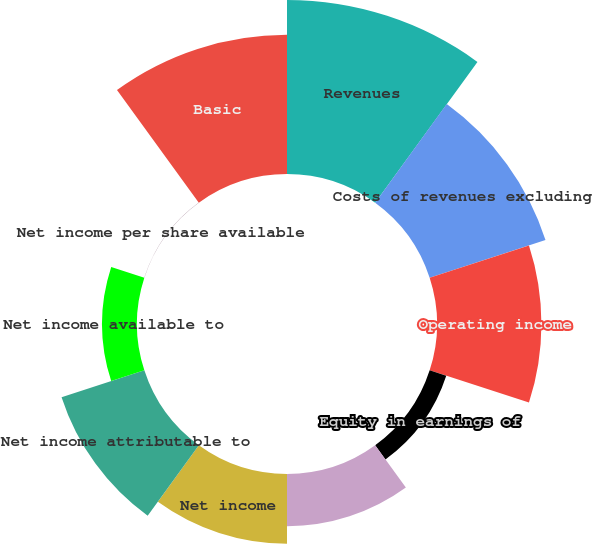Convert chart. <chart><loc_0><loc_0><loc_500><loc_500><pie_chart><fcel>Revenues<fcel>Costs of revenues excluding<fcel>Operating income<fcel>Equity in earnings of<fcel>Income from continuing<fcel>Net income<fcel>Net income attributable to<fcel>Net income available to<fcel>Net income per share available<fcel>Basic<nl><fcel>21.73%<fcel>15.21%<fcel>13.04%<fcel>2.18%<fcel>6.52%<fcel>8.7%<fcel>10.87%<fcel>4.35%<fcel>0.01%<fcel>17.39%<nl></chart> 